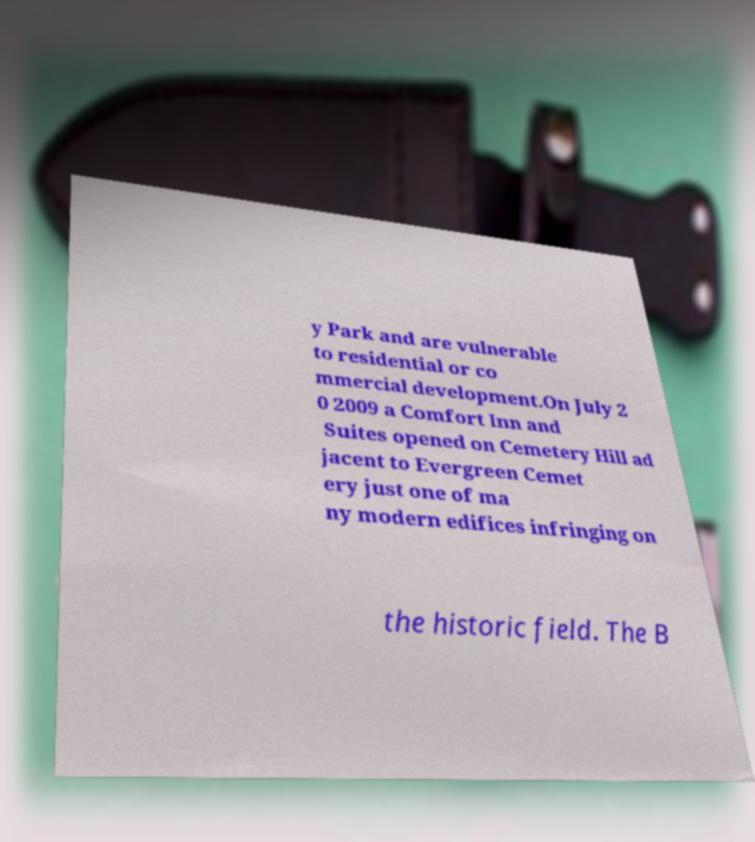For documentation purposes, I need the text within this image transcribed. Could you provide that? y Park and are vulnerable to residential or co mmercial development.On July 2 0 2009 a Comfort Inn and Suites opened on Cemetery Hill ad jacent to Evergreen Cemet ery just one of ma ny modern edifices infringing on the historic field. The B 